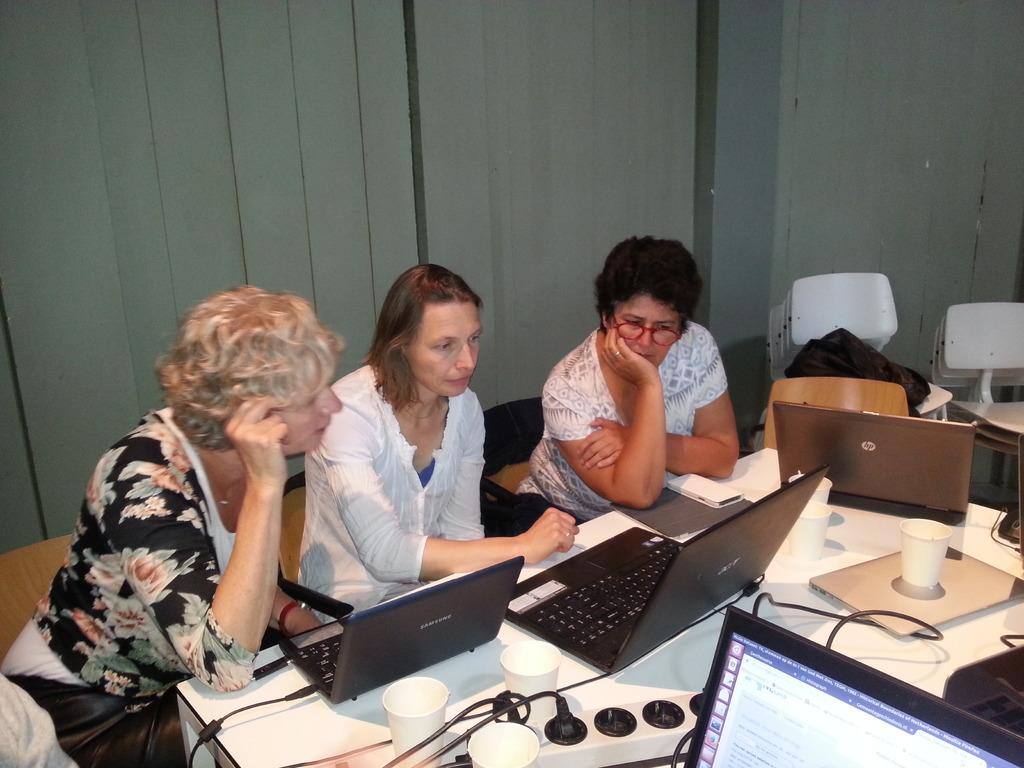How many people are in the image? There are three women in the image. What are the women doing in the image? The women are seated and working on their laptops. What type of coil is being used by the women in the image? There is no coil present in the image; the women are working on their laptops. Can you see any crows in the image? There are no crows present in the image. 